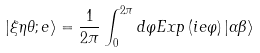Convert formula to latex. <formula><loc_0><loc_0><loc_500><loc_500>\ \left | \xi \eta \theta ; e \right \rangle = \frac { 1 } { 2 \pi } \int _ { 0 } ^ { 2 \pi } d \varphi E x p \left ( i e \varphi \right ) \left | \alpha \beta \right \rangle</formula> 